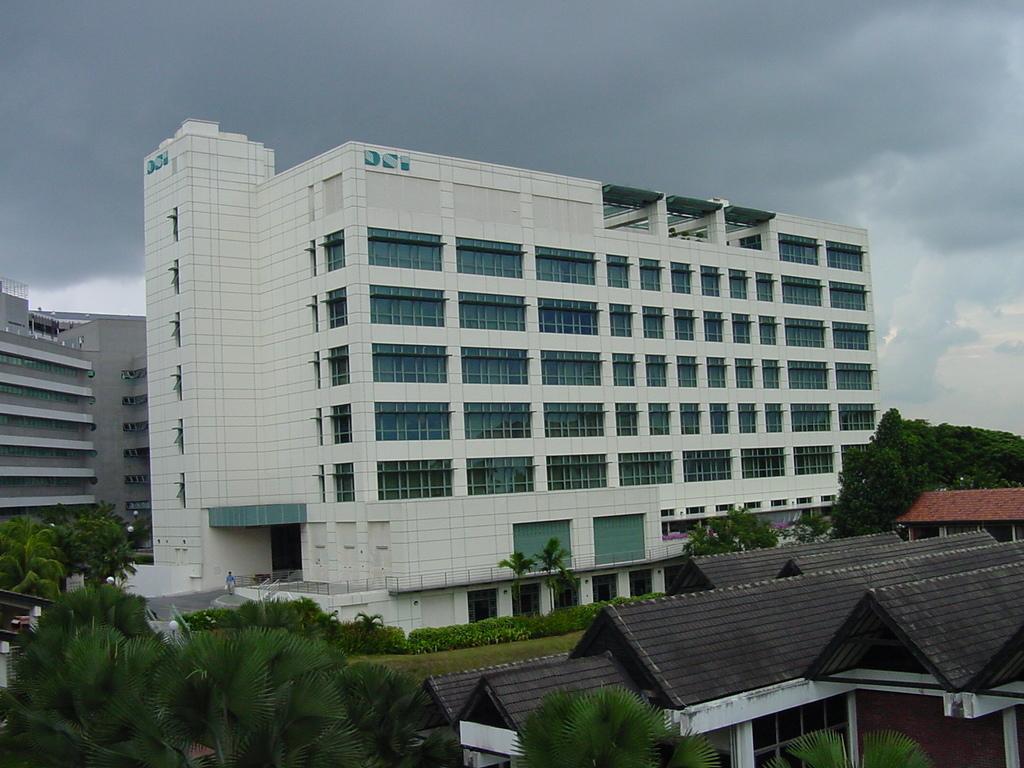Can you describe this image briefly? In this image, we can see buildings, houses, trees, plants, glasses, walls. Background there is a cloudy sky. 